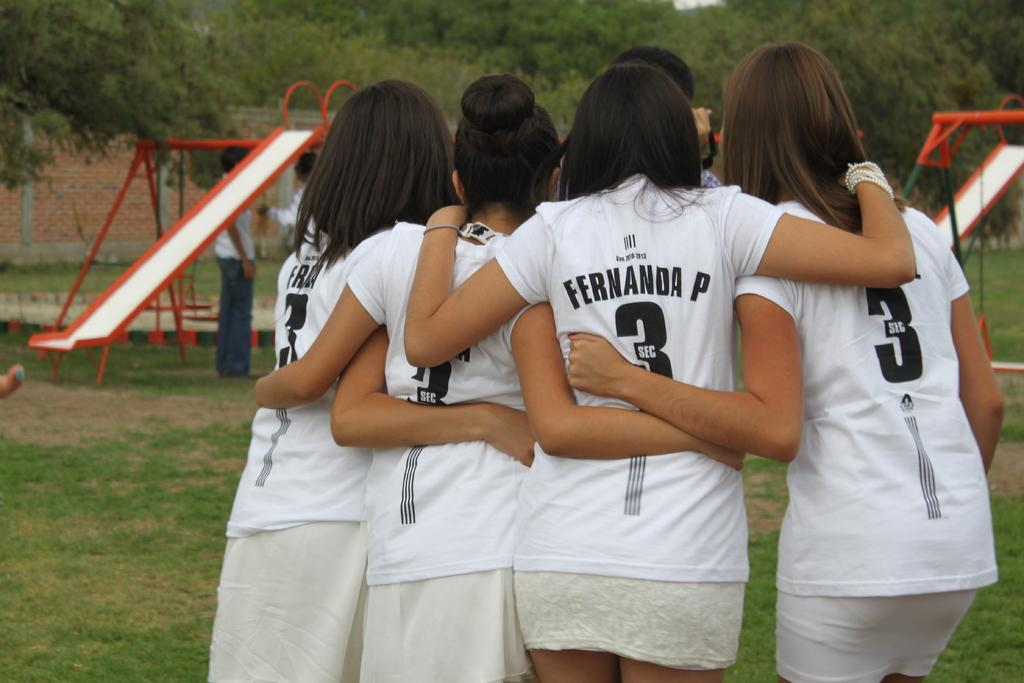<image>
Give a short and clear explanation of the subsequent image. A group of girls, one of which has Fernanda P on the back of her shirt. 